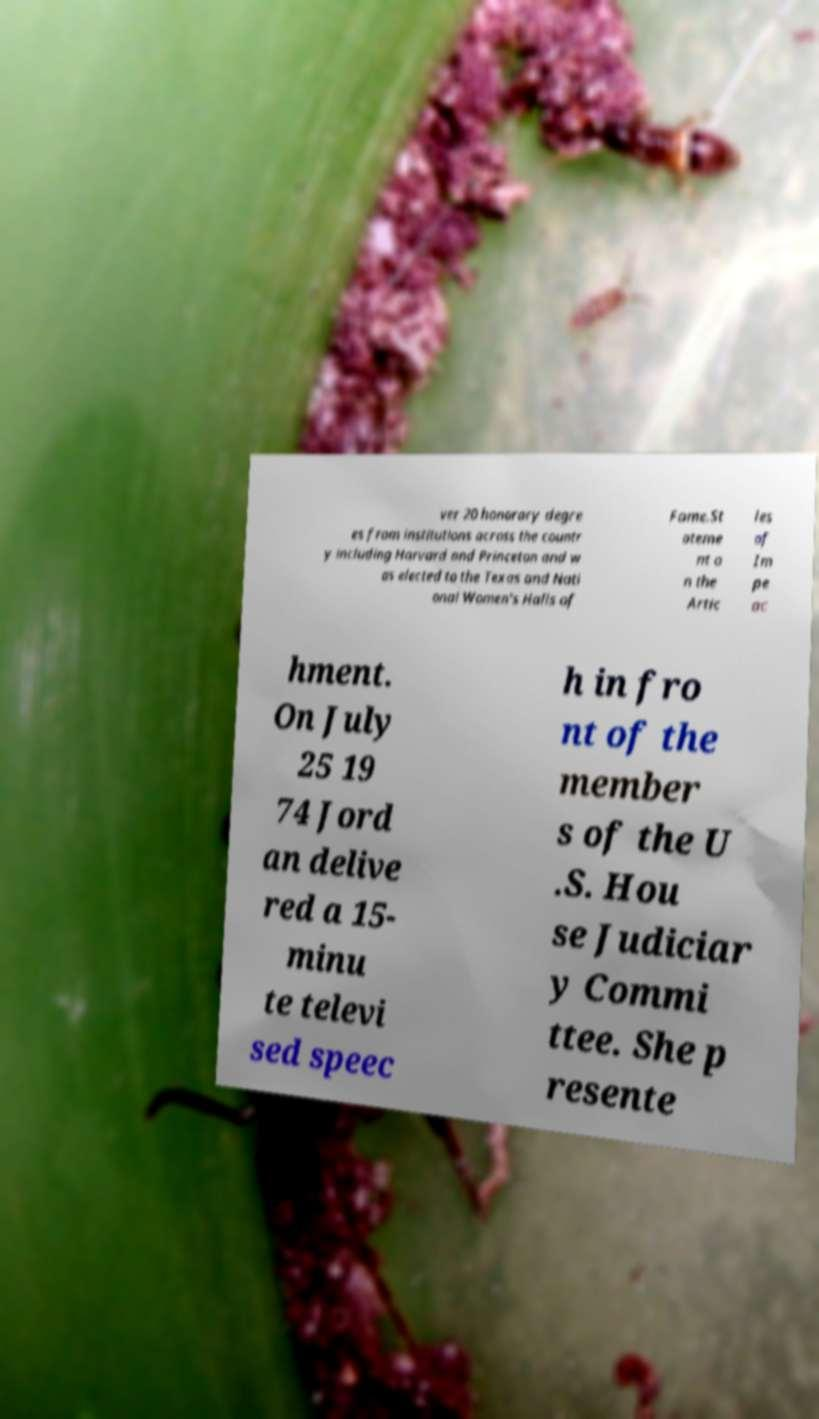I need the written content from this picture converted into text. Can you do that? ver 20 honorary degre es from institutions across the countr y including Harvard and Princeton and w as elected to the Texas and Nati onal Women's Halls of Fame.St ateme nt o n the Artic les of Im pe ac hment. On July 25 19 74 Jord an delive red a 15- minu te televi sed speec h in fro nt of the member s of the U .S. Hou se Judiciar y Commi ttee. She p resente 